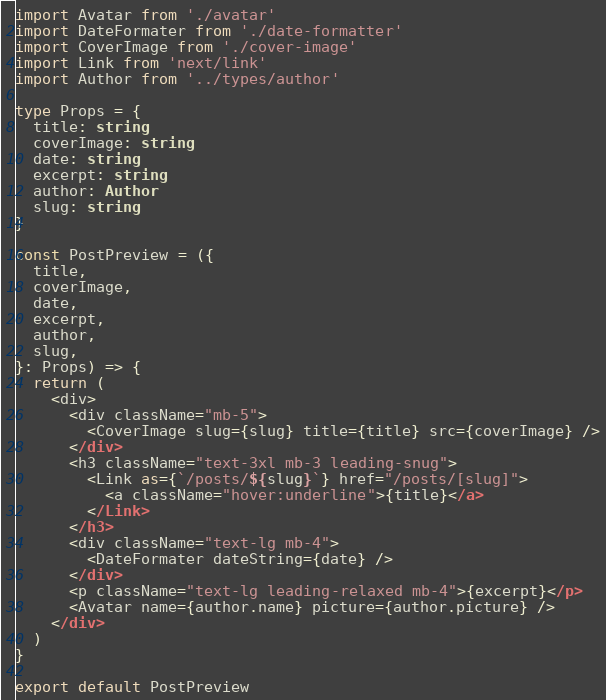Convert code to text. <code><loc_0><loc_0><loc_500><loc_500><_TypeScript_>import Avatar from './avatar'
import DateFormater from './date-formatter'
import CoverImage from './cover-image'
import Link from 'next/link'
import Author from '../types/author'

type Props = {
  title: string
  coverImage: string
  date: string
  excerpt: string
  author: Author
  slug: string
}

const PostPreview = ({
  title,
  coverImage,
  date,
  excerpt,
  author,
  slug,
}: Props) => {
  return (
    <div>
      <div className="mb-5">
        <CoverImage slug={slug} title={title} src={coverImage} />
      </div>
      <h3 className="text-3xl mb-3 leading-snug">
        <Link as={`/posts/${slug}`} href="/posts/[slug]">
          <a className="hover:underline">{title}</a>
        </Link>
      </h3>
      <div className="text-lg mb-4">
        <DateFormater dateString={date} />
      </div>
      <p className="text-lg leading-relaxed mb-4">{excerpt}</p>
      <Avatar name={author.name} picture={author.picture} />
    </div>
  )
}

export default PostPreview
</code> 